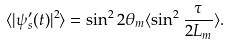<formula> <loc_0><loc_0><loc_500><loc_500>\langle | \psi _ { s } ^ { \prime } ( t ) | ^ { 2 } \rangle = \sin ^ { 2 } 2 \theta _ { m } \langle \sin ^ { 2 } { \frac { \tau } { 2 L _ { m } } } \rangle .</formula> 